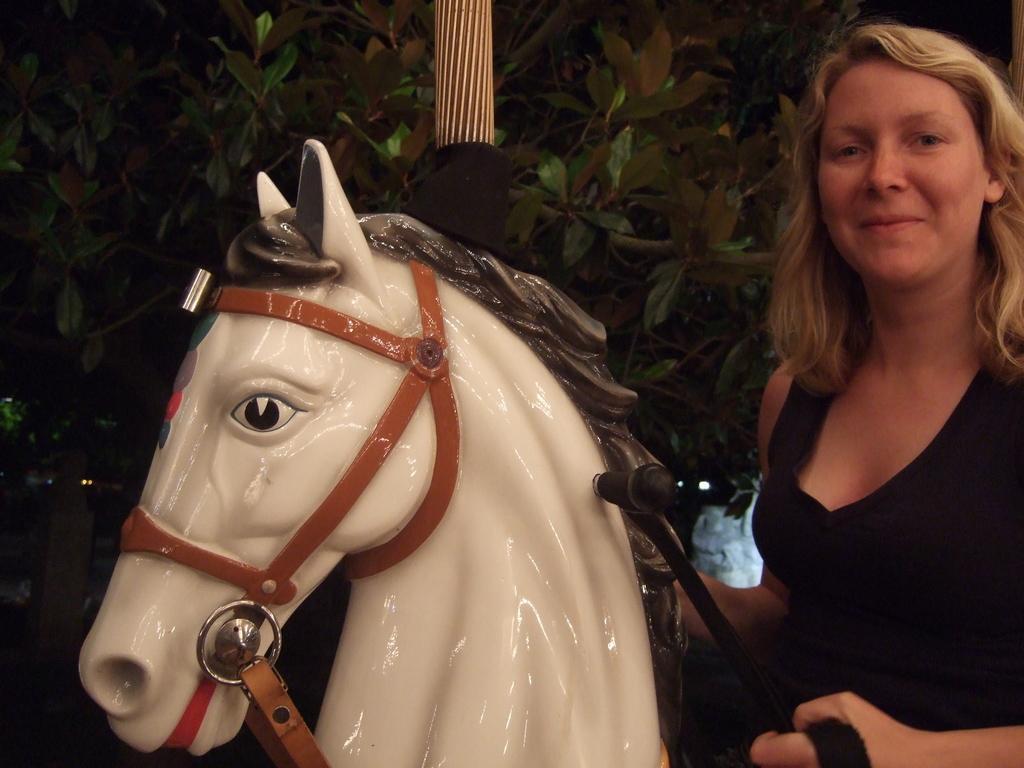How would you summarize this image in a sentence or two? In this image I can see a woman wearing black dress is sitting on a toy horse which is cream, brown and black in color. I can see she is holding a black colored object in her hand. In the background I can see a tree. 